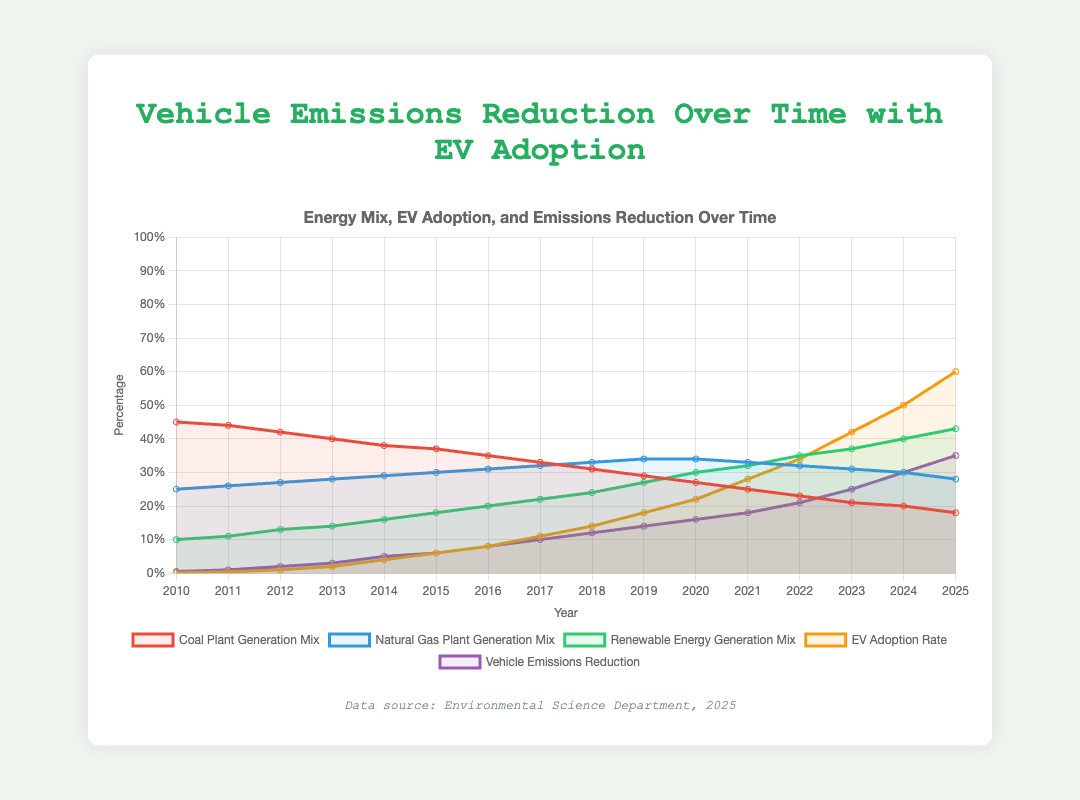What year saw the highest Renewable Energy Generation Mix? Look for the highest point on the line representing Renewable Energy Generation Mix and read the corresponding year. From the chart, the highest Renewable Energy Generation Mix is in 2025.
Answer: 2025 How much did the Vehicle Emissions Reduction increase from 2010 to 2015? Identify the Vehicle Emissions Reduction values for 2010 and 2015. In 2010, it is 0.005, and in 2015, it is 0.06. Subtract to find the increase: 0.06 - 0.005 = 0.055.
Answer: 0.055 Which year had the lowest Coal Plant Generation Mix, and what was the value? Look for the lowest point on the line representing Coal Plant Generation Mix and note the year and value. The lowest Coal Plant Generation Mix is in 2025, and the value is 0.18.
Answer: 2025, 0.18 In which year was the EV Adoption Rate first above 0.3? Locate the point where the EV Adoption Rate first surpasses 0.3 on the chart. This happens in the year 2022.
Answer: 2022 What was the average Vehicle Emissions Reduction between 2020 and 2025? Find the Vehicle Emissions Reduction values for the years 2020 to 2025 (0.16, 0.18, 0.21, 0.25, 0.30, 0.35). Calculate the average: (0.16 + 0.18 + 0.21 + 0.25 + 0.30 + 0.35) / 6 = 0.2417.
Answer: 0.2417 Did the Natural Gas Plant Generation Mix increase or decrease between 2017 and 2020? Identify the values of Natural Gas Plant Generation Mix in 2017 (0.32) and 2020 (0.34). Compare the two values: 0.34 - 0.32 indicates an increase.
Answer: Increase Which had a higher proportion in 2022: the Renewable Energy Generation Mix or Coal Plant Generation Mix? Compare the values of Renewable Energy Generation Mix (0.35) and Coal Plant Generation Mix (0.23) in 2022. The Renewable Energy Generation Mix is higher.
Answer: Renewable Energy Generation Mix What is the sum of the Renewable Energy Generation Mix and EV Adoption Rate in 2025? Find the values of Renewable Energy Generation Mix (0.43) and EV Adoption Rate (0.60) in 2025 and sum them: 0.43 + 0.60 = 1.03.
Answer: 1.03 How did the Vehicle Emissions Reduction change from the year with the lowest EV Adoption Rate to the year with the highest EV Adoption Rate? Identify the years with the lowest (2010, 0.002) and highest (2025, 0.60) EV Adoption Rates and their corresponding Vehicle Emissions Reduction (2010: 0.005, 2025: 0.35). Calculate the change: 0.35 - 0.005 = 0.345.
Answer: 0.345 Between 2015 and 2020, which energy generation mix had the most significant increase? Calculate the difference in values for each energy generation mix between 2015 and 2020. Coal: 0.37 to 0.27 (-0.1), Natural Gas: 0.30 to 0.34 (+0.04), Renewable Energy: 0.18 to 0.30 (+0.12). The Renewable Energy Generation Mix shows the most significant increase (0.12).
Answer: Renewable Energy Generation Mix 